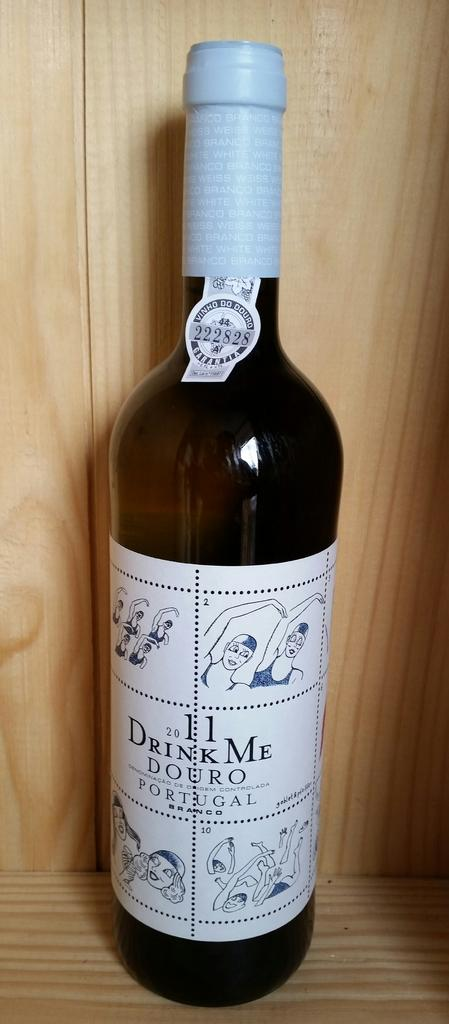<image>
Share a concise interpretation of the image provided. A bottle of Drink Me Douro Portugal still sealed 